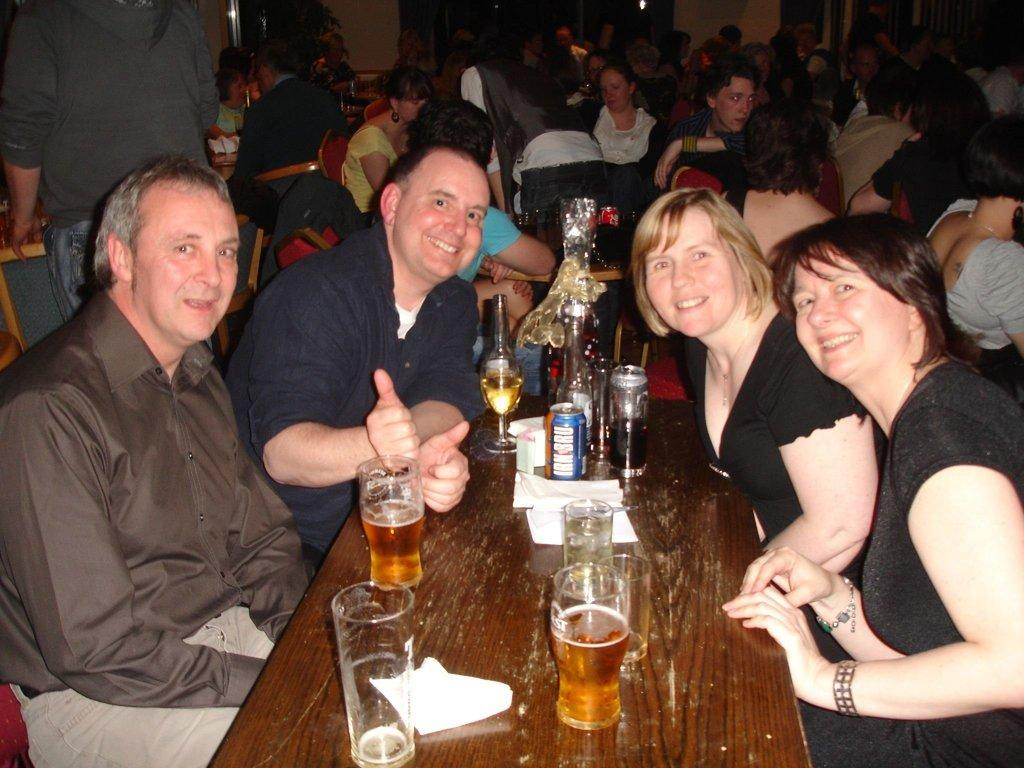How many people are in the image? There is a group of persons in the image. What are the persons in the image doing? The persons are sitting and having their drinks. What can be seen on the table in the image? There are glasses and bottles on the table. What type of battle is taking place in the image? There is no battle present in the image; it features a group of persons sitting and having drinks. How many divisions can be seen in the image? There is no division present in the image; it features a group of persons sitting and having drinks. 